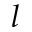Convert formula to latex. <formula><loc_0><loc_0><loc_500><loc_500>l</formula> 